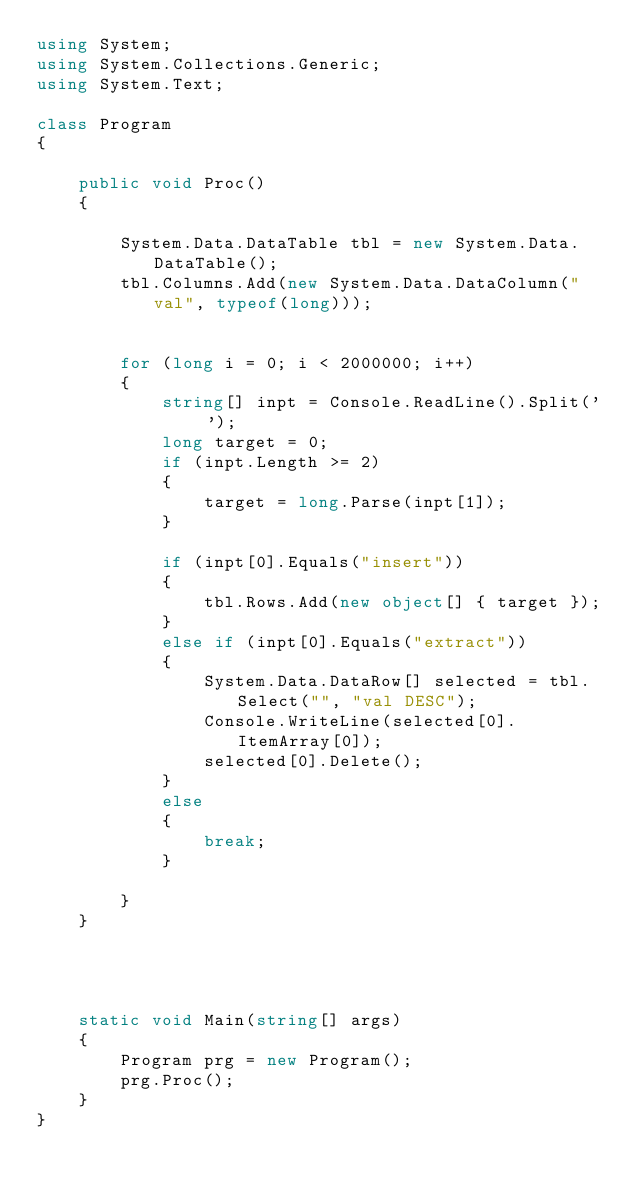<code> <loc_0><loc_0><loc_500><loc_500><_C#_>using System;
using System.Collections.Generic;
using System.Text;

class Program
{

    public void Proc()
    {

        System.Data.DataTable tbl = new System.Data.DataTable();
        tbl.Columns.Add(new System.Data.DataColumn("val", typeof(long)));


        for (long i = 0; i < 2000000; i++)
        {
            string[] inpt = Console.ReadLine().Split(' ');
            long target = 0;
            if (inpt.Length >= 2)
            {
                target = long.Parse(inpt[1]);
            }

            if (inpt[0].Equals("insert"))
            {
                tbl.Rows.Add(new object[] { target });
            }
            else if (inpt[0].Equals("extract"))
            {
                System.Data.DataRow[] selected = tbl.Select("", "val DESC");
                Console.WriteLine(selected[0].ItemArray[0]);
                selected[0].Delete();
            }
            else
            {
                break;
            }
             
        }
    }




    static void Main(string[] args)
    {
        Program prg = new Program();
        prg.Proc();
    }
}</code> 